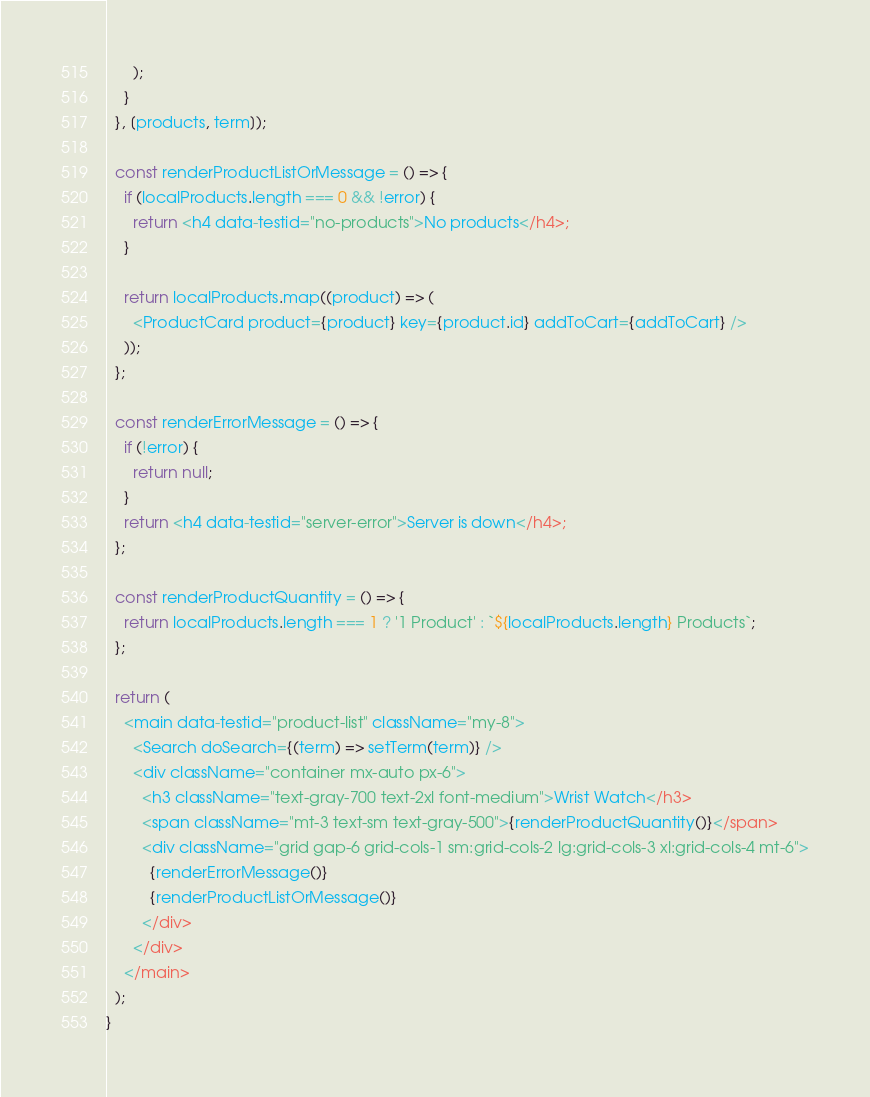<code> <loc_0><loc_0><loc_500><loc_500><_JavaScript_>      );
    }
  }, [products, term]);

  const renderProductListOrMessage = () => {
    if (localProducts.length === 0 && !error) {
      return <h4 data-testid="no-products">No products</h4>;
    }

    return localProducts.map((product) => (
      <ProductCard product={product} key={product.id} addToCart={addToCart} />
    ));
  };

  const renderErrorMessage = () => {
    if (!error) {
      return null;
    }
    return <h4 data-testid="server-error">Server is down</h4>;
  };

  const renderProductQuantity = () => {
    return localProducts.length === 1 ? '1 Product' : `${localProducts.length} Products`;
  };

  return (
    <main data-testid="product-list" className="my-8">
      <Search doSearch={(term) => setTerm(term)} />
      <div className="container mx-auto px-6">
        <h3 className="text-gray-700 text-2xl font-medium">Wrist Watch</h3>
        <span className="mt-3 text-sm text-gray-500">{renderProductQuantity()}</span>
        <div className="grid gap-6 grid-cols-1 sm:grid-cols-2 lg:grid-cols-3 xl:grid-cols-4 mt-6">
          {renderErrorMessage()}
          {renderProductListOrMessage()}
        </div>
      </div>
    </main>
  );
}
</code> 